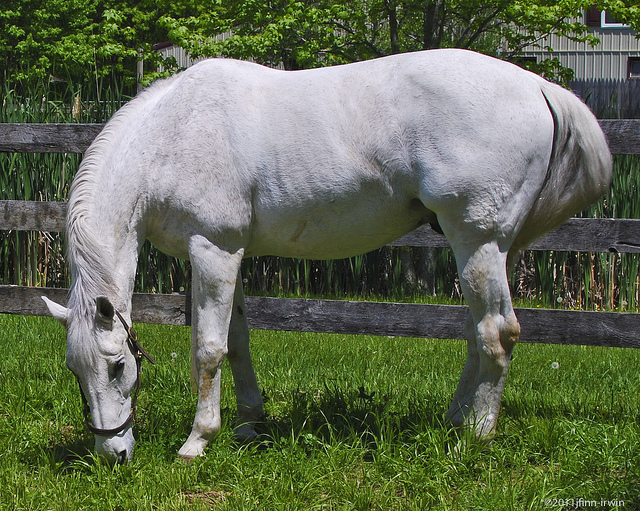What's the main subject of the image? The main subject of the image is a white horse, which appears to be peacefully grazing on the grass. 